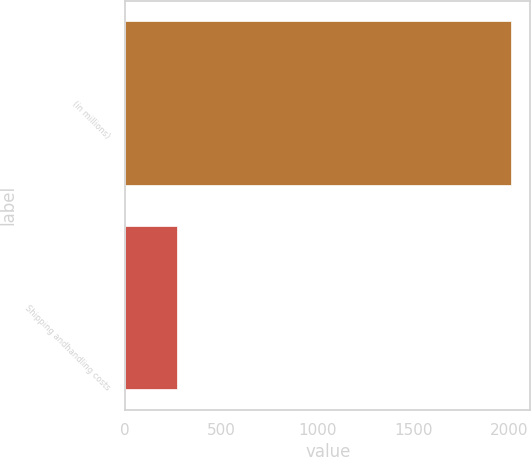Convert chart to OTSL. <chart><loc_0><loc_0><loc_500><loc_500><bar_chart><fcel>(in millions)<fcel>Shipping andhandling costs<nl><fcel>2008<fcel>270<nl></chart> 